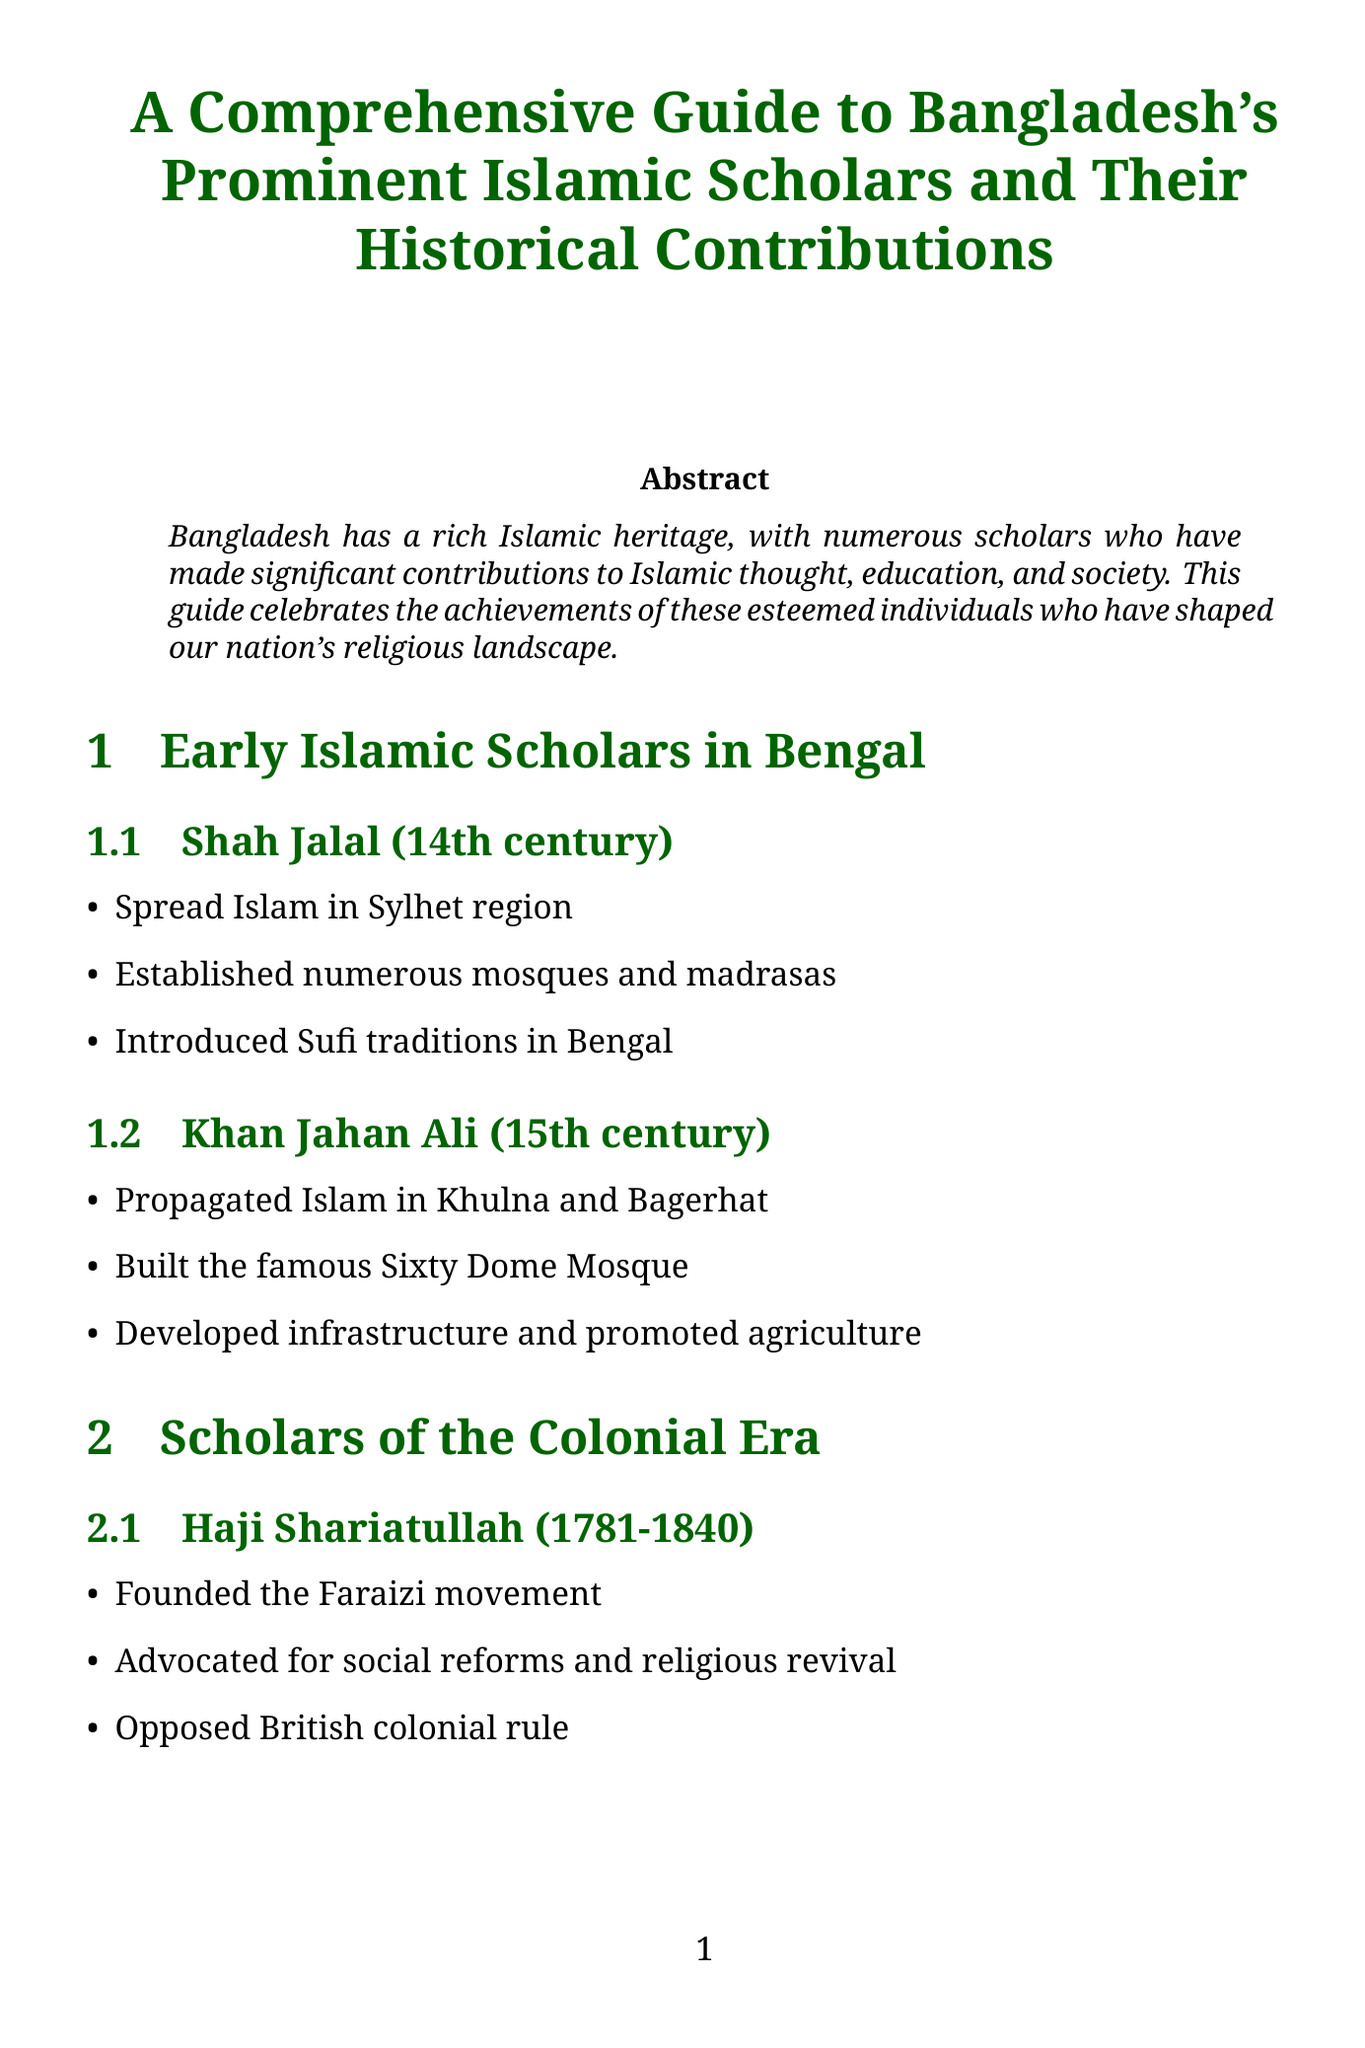What is the title of the guide? The title of the guide is presented prominently at the beginning, summarizing its focus on scholars and their contributions.
Answer: A Comprehensive Guide to Bangladesh's Prominent Islamic Scholars and Their Historical Contributions Who established the Sixty Dome Mosque? The guide details Khan Jahan Ali's contributions, including the establishment of the Sixty Dome Mosque in Bagerhat.
Answer: Khan Jahan Ali What period did Haji Shariatullah belong to? The document states the period Haji Shariatullah lived in, marking significant contributions during the colonial era.
Answer: 1781-1840 Which scholar led the Hefazat-e-Islam movement? Shah Ahmad Shafi's role as a leader of the Hefazat-e-Islam movement is specified in the post-independence scholars section.
Answer: Shah Ahmad Shafi What significant impact have these scholars had on national policies? The document lists various contributions of scholars, including their influence on national policies and legislation.
Answer: Influence on national policies and legislation Name a contemporary scholar who focuses on Islamic finance. The guide identifies a contemporary scholar who specializes in Islamic finance and economics, emphasizing modern educational contributions.
Answer: Dr. Muhammad Asad-ul Islam What movement did Tahmina Akter found? The guide highlights Tahmina Akter's role in founding a movement focused on women's education within the Islamic context.
Answer: Women's Islamic Education Movement When did Dr. Safiya Akhter start her academic career? The document specifies the time period in which Dr. Safiya Akhter began her contributions to Hadith studies and gender equality.
Answer: 1980-present How many sections are there in the guide? The document is organized into sections that cover different categories of scholars, providing an overview of its structure.
Answer: Five 